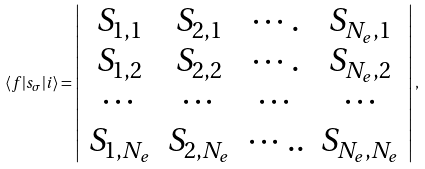Convert formula to latex. <formula><loc_0><loc_0><loc_500><loc_500>\langle f | s _ { \sigma } | i \rangle = \left | \begin{array} { c c c c } S _ { 1 , 1 } & S _ { 2 , 1 } & \cdots . & S _ { N _ { e } , 1 } \\ S _ { 1 , 2 } & S _ { 2 , 2 } & \cdots . & S _ { N _ { e } , 2 } \\ \cdots & \cdots & \cdots & \cdots \\ S _ { 1 , N _ { e } } & S _ { 2 , N _ { e } } & \cdots . . & S _ { N _ { e } , N _ { e } } \end{array} \right | ,</formula> 